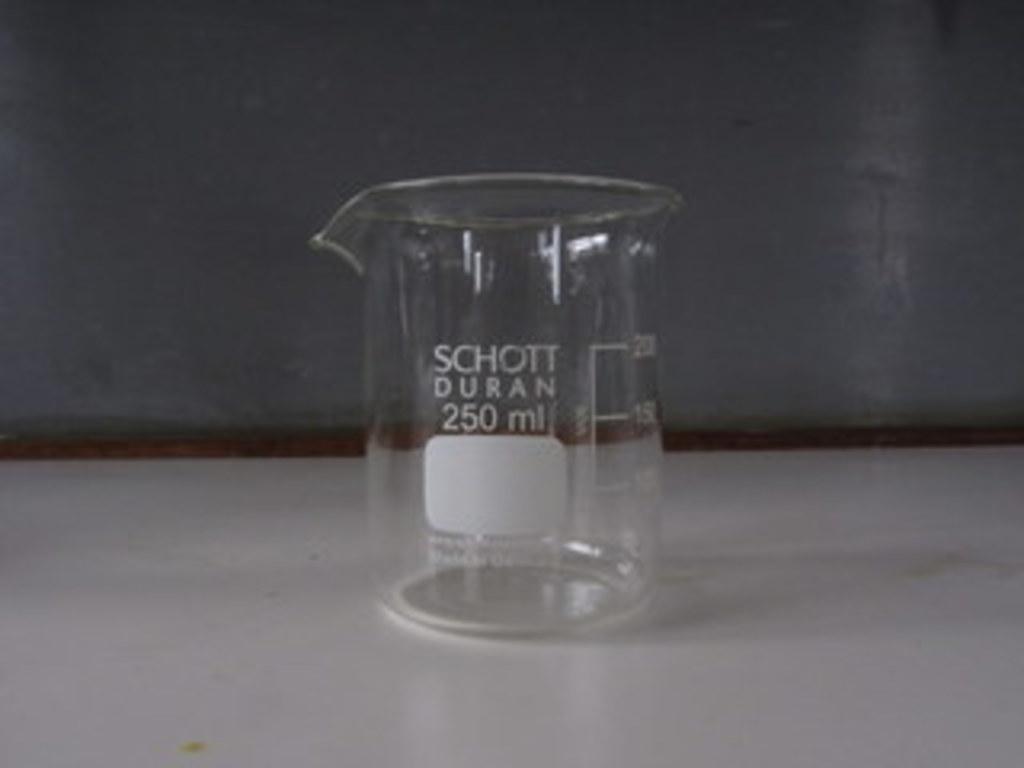How many ml?
Your response must be concise. 250. Who makes the beaker?
Provide a succinct answer. Schott duran. 